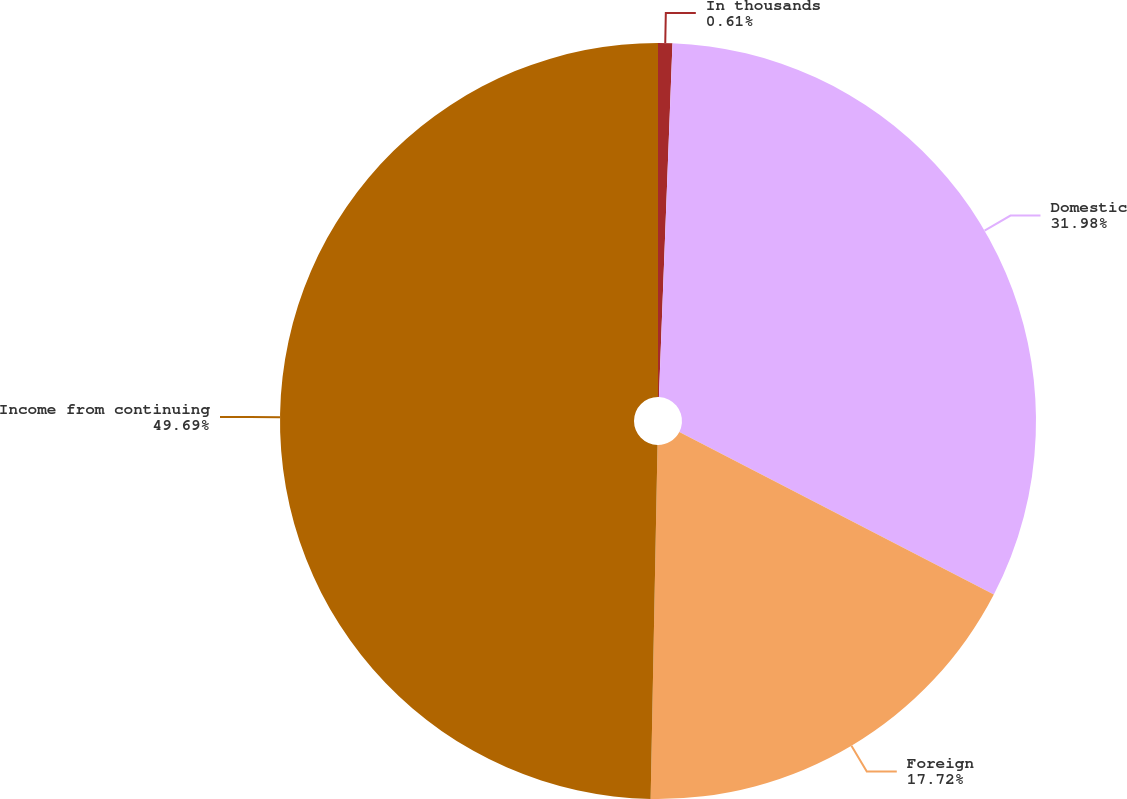Convert chart. <chart><loc_0><loc_0><loc_500><loc_500><pie_chart><fcel>In thousands<fcel>Domestic<fcel>Foreign<fcel>Income from continuing<nl><fcel>0.61%<fcel>31.98%<fcel>17.72%<fcel>49.69%<nl></chart> 